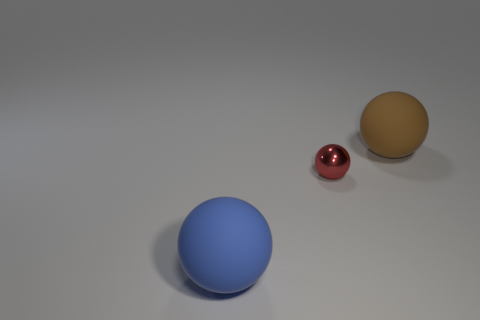What material is the blue object that is the same shape as the red thing?
Offer a terse response. Rubber. What number of rubber objects are red objects or tiny blue spheres?
Your answer should be very brief. 0. There is a brown object that is the same material as the big blue thing; what shape is it?
Offer a very short reply. Sphere. What number of other big blue rubber things have the same shape as the large blue object?
Provide a succinct answer. 0. Is the shape of the rubber thing in front of the big brown thing the same as the big rubber object behind the blue matte sphere?
Provide a short and direct response. Yes. How many things are rubber things or objects to the left of the brown ball?
Make the answer very short. 3. What number of other rubber objects have the same size as the blue thing?
Your answer should be very brief. 1. How many purple objects are tiny balls or balls?
Make the answer very short. 0. What is the shape of the rubber thing in front of the large rubber thing that is behind the large blue thing?
Provide a succinct answer. Sphere. There is a thing that is the same size as the brown rubber ball; what is its shape?
Ensure brevity in your answer.  Sphere. 